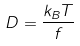<formula> <loc_0><loc_0><loc_500><loc_500>D = \frac { k _ { B } T } { f }</formula> 